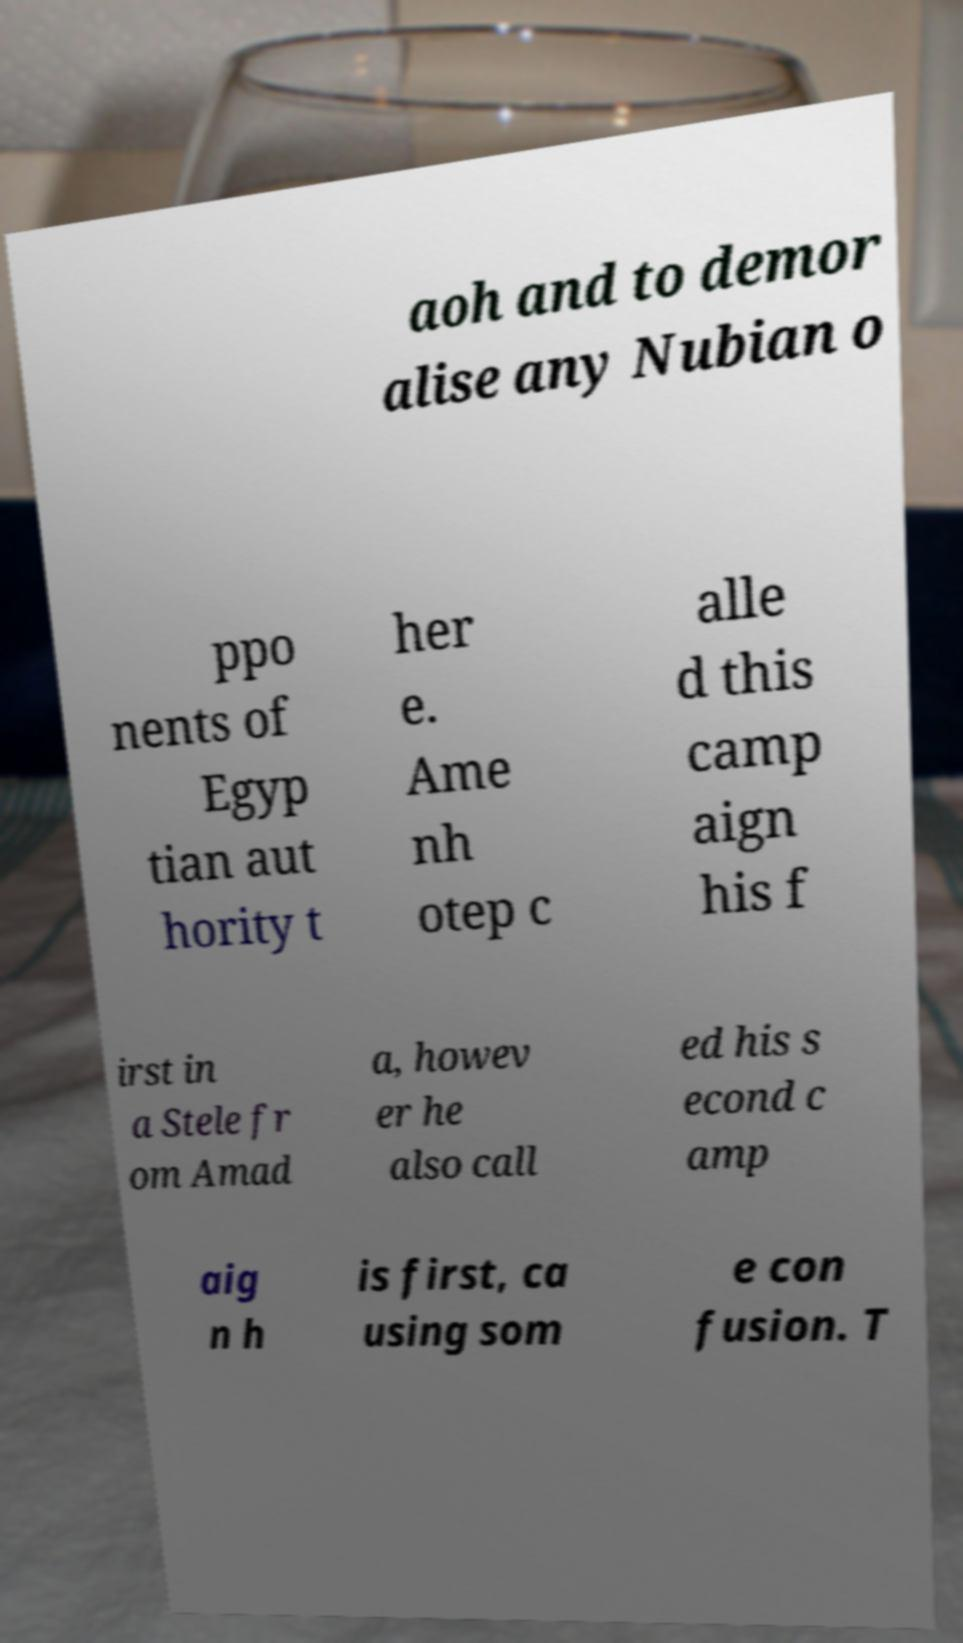I need the written content from this picture converted into text. Can you do that? aoh and to demor alise any Nubian o ppo nents of Egyp tian aut hority t her e. Ame nh otep c alle d this camp aign his f irst in a Stele fr om Amad a, howev er he also call ed his s econd c amp aig n h is first, ca using som e con fusion. T 